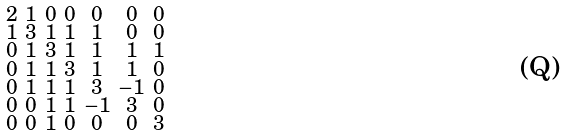<formula> <loc_0><loc_0><loc_500><loc_500>\begin{smallmatrix} 2 & 1 & 0 & 0 & 0 & 0 & 0 \\ 1 & 3 & 1 & 1 & 1 & 0 & 0 \\ 0 & 1 & 3 & 1 & 1 & 1 & 1 \\ 0 & 1 & 1 & 3 & 1 & 1 & 0 \\ 0 & 1 & 1 & 1 & 3 & - 1 & 0 \\ 0 & 0 & 1 & 1 & - 1 & 3 & 0 \\ 0 & 0 & 1 & 0 & 0 & 0 & 3 \end{smallmatrix}</formula> 